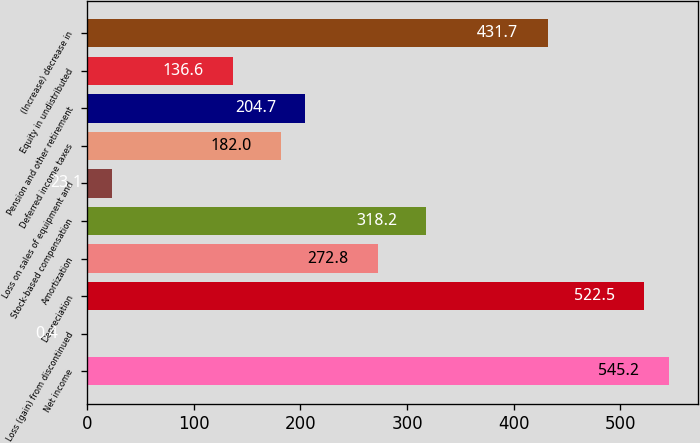Convert chart to OTSL. <chart><loc_0><loc_0><loc_500><loc_500><bar_chart><fcel>Net income<fcel>Loss (gain) from discontinued<fcel>Depreciation<fcel>Amortization<fcel>Stock-based compensation<fcel>Loss on sales of equipment and<fcel>Deferred income taxes<fcel>Pension and other retirement<fcel>Equity in undistributed<fcel>(Increase) decrease in<nl><fcel>545.2<fcel>0.4<fcel>522.5<fcel>272.8<fcel>318.2<fcel>23.1<fcel>182<fcel>204.7<fcel>136.6<fcel>431.7<nl></chart> 